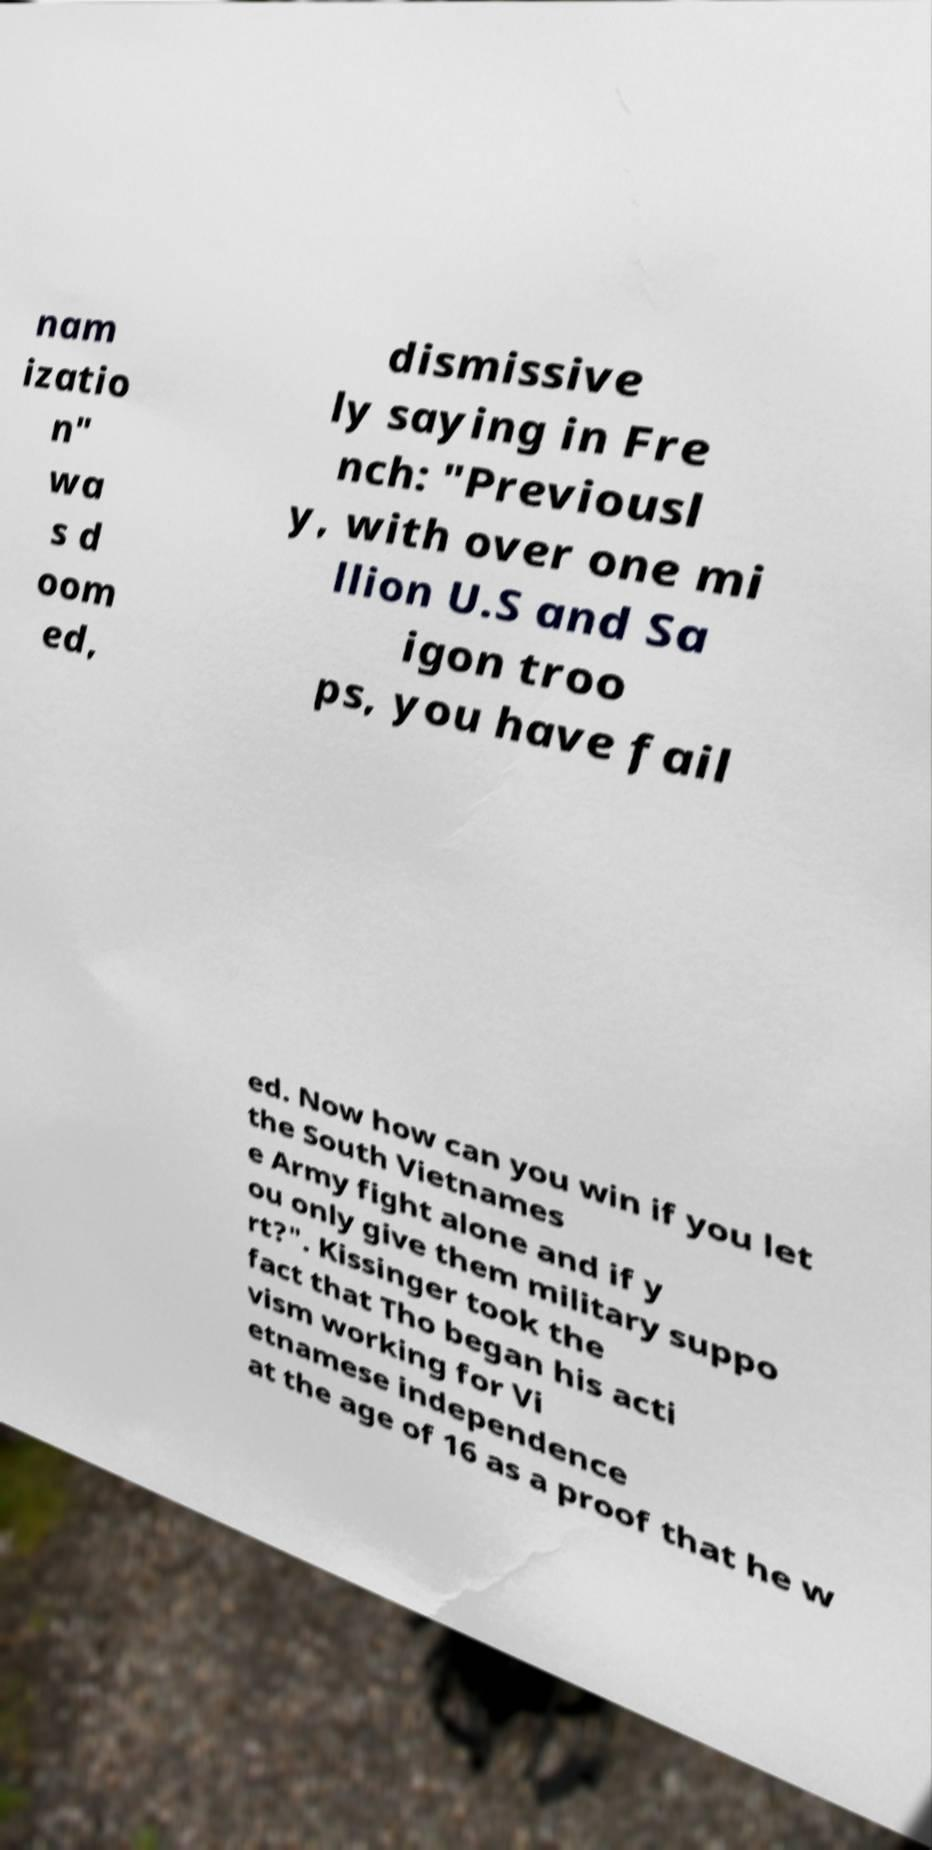Could you assist in decoding the text presented in this image and type it out clearly? nam izatio n" wa s d oom ed, dismissive ly saying in Fre nch: "Previousl y, with over one mi llion U.S and Sa igon troo ps, you have fail ed. Now how can you win if you let the South Vietnames e Army fight alone and if y ou only give them military suppo rt?". Kissinger took the fact that Tho began his acti vism working for Vi etnamese independence at the age of 16 as a proof that he w 